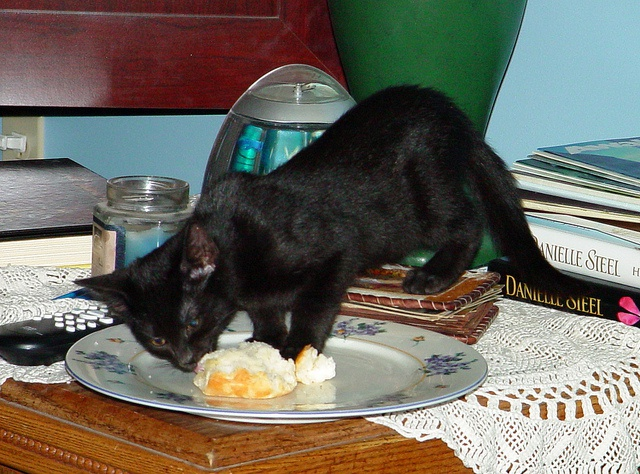Describe the objects in this image and their specific colors. I can see cat in maroon, black, and gray tones, dining table in maroon, white, brown, and darkgray tones, vase in maroon, darkgreen, black, and teal tones, bottle in maroon, gray, darkgray, teal, and black tones, and book in maroon, lightgray, darkgray, lightblue, and gray tones in this image. 